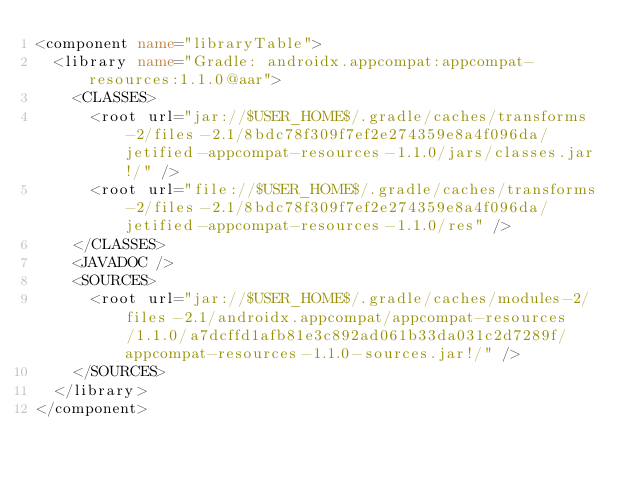Convert code to text. <code><loc_0><loc_0><loc_500><loc_500><_XML_><component name="libraryTable">
  <library name="Gradle: androidx.appcompat:appcompat-resources:1.1.0@aar">
    <CLASSES>
      <root url="jar://$USER_HOME$/.gradle/caches/transforms-2/files-2.1/8bdc78f309f7ef2e274359e8a4f096da/jetified-appcompat-resources-1.1.0/jars/classes.jar!/" />
      <root url="file://$USER_HOME$/.gradle/caches/transforms-2/files-2.1/8bdc78f309f7ef2e274359e8a4f096da/jetified-appcompat-resources-1.1.0/res" />
    </CLASSES>
    <JAVADOC />
    <SOURCES>
      <root url="jar://$USER_HOME$/.gradle/caches/modules-2/files-2.1/androidx.appcompat/appcompat-resources/1.1.0/a7dcffd1afb81e3c892ad061b33da031c2d7289f/appcompat-resources-1.1.0-sources.jar!/" />
    </SOURCES>
  </library>
</component></code> 